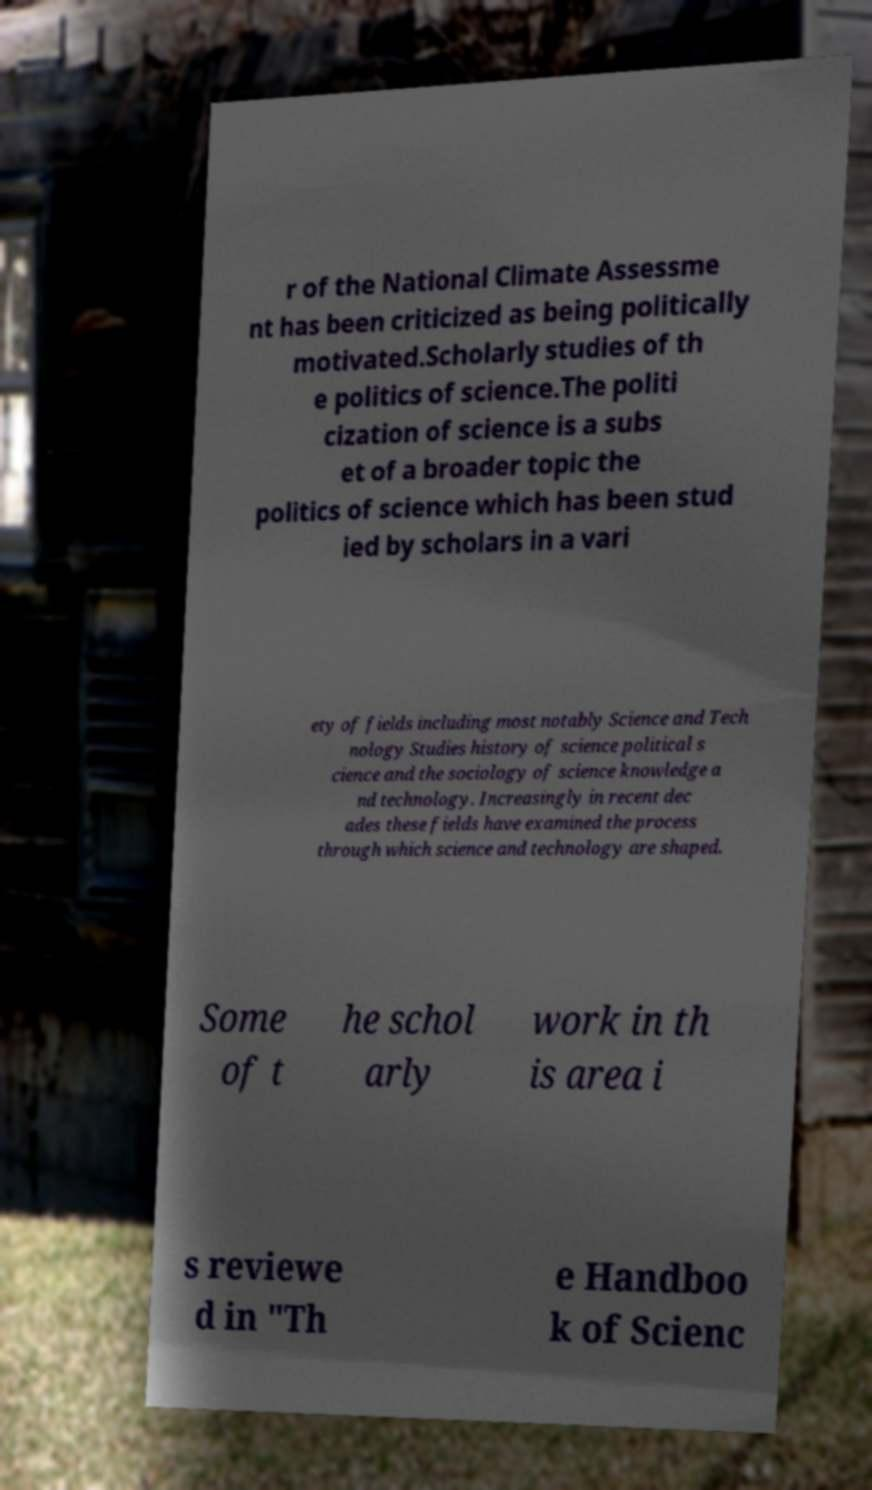Could you extract and type out the text from this image? r of the National Climate Assessme nt has been criticized as being politically motivated.Scholarly studies of th e politics of science.The politi cization of science is a subs et of a broader topic the politics of science which has been stud ied by scholars in a vari ety of fields including most notably Science and Tech nology Studies history of science political s cience and the sociology of science knowledge a nd technology. Increasingly in recent dec ades these fields have examined the process through which science and technology are shaped. Some of t he schol arly work in th is area i s reviewe d in "Th e Handboo k of Scienc 